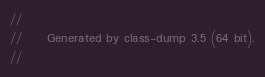Convert code to text. <code><loc_0><loc_0><loc_500><loc_500><_C_>//
//     Generated by class-dump 3.5 (64 bit).
//</code> 